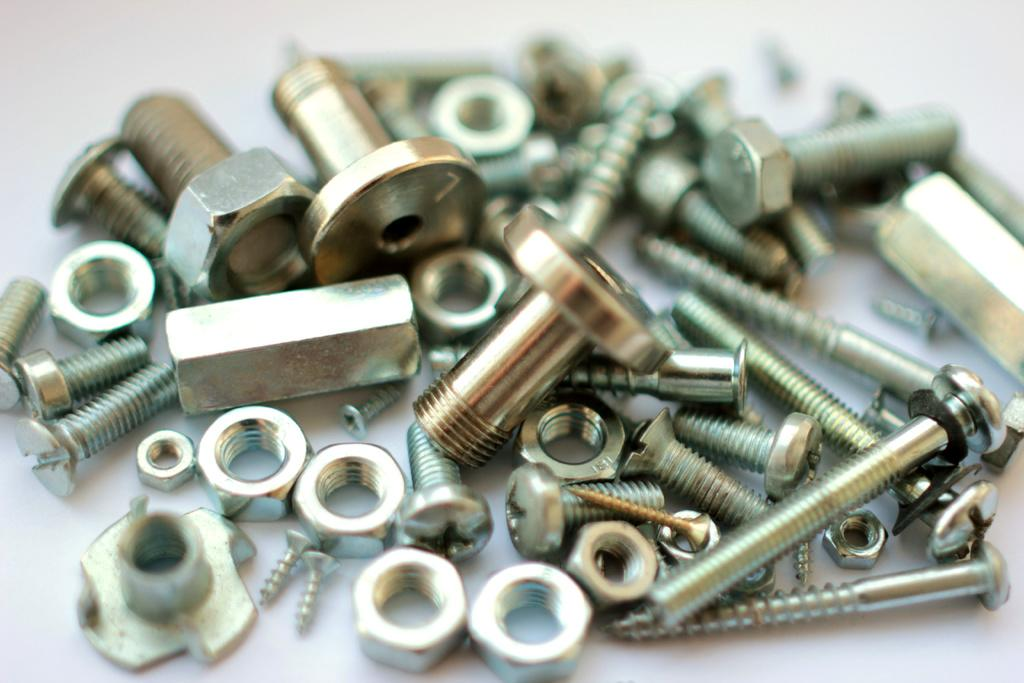What type of objects can be seen in the image? There are nuts and screws in the image. Can you describe the nuts in the image? The nuts in the image are small, round fasteners used to hold objects together. How do the screws in the image differ from the nuts? The screws in the image have a threaded shaft and a head, which allows them to be turned and inserted into objects to hold them together. What type of oil is being used to reduce friction between the nuts and screws in the image? There is no oil present in the image, nor is there any indication of friction between the nuts and screws. 